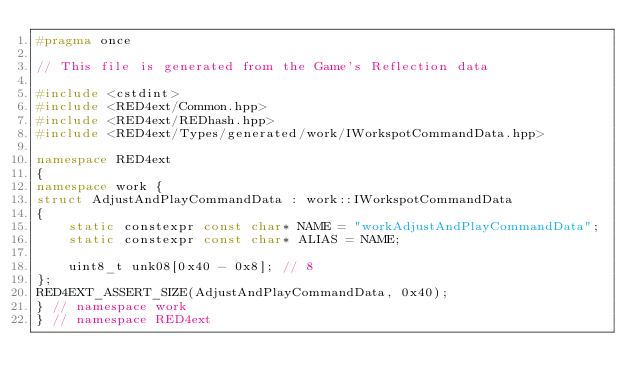<code> <loc_0><loc_0><loc_500><loc_500><_C++_>#pragma once

// This file is generated from the Game's Reflection data

#include <cstdint>
#include <RED4ext/Common.hpp>
#include <RED4ext/REDhash.hpp>
#include <RED4ext/Types/generated/work/IWorkspotCommandData.hpp>

namespace RED4ext
{
namespace work { 
struct AdjustAndPlayCommandData : work::IWorkspotCommandData
{
    static constexpr const char* NAME = "workAdjustAndPlayCommandData";
    static constexpr const char* ALIAS = NAME;

    uint8_t unk08[0x40 - 0x8]; // 8
};
RED4EXT_ASSERT_SIZE(AdjustAndPlayCommandData, 0x40);
} // namespace work
} // namespace RED4ext
</code> 